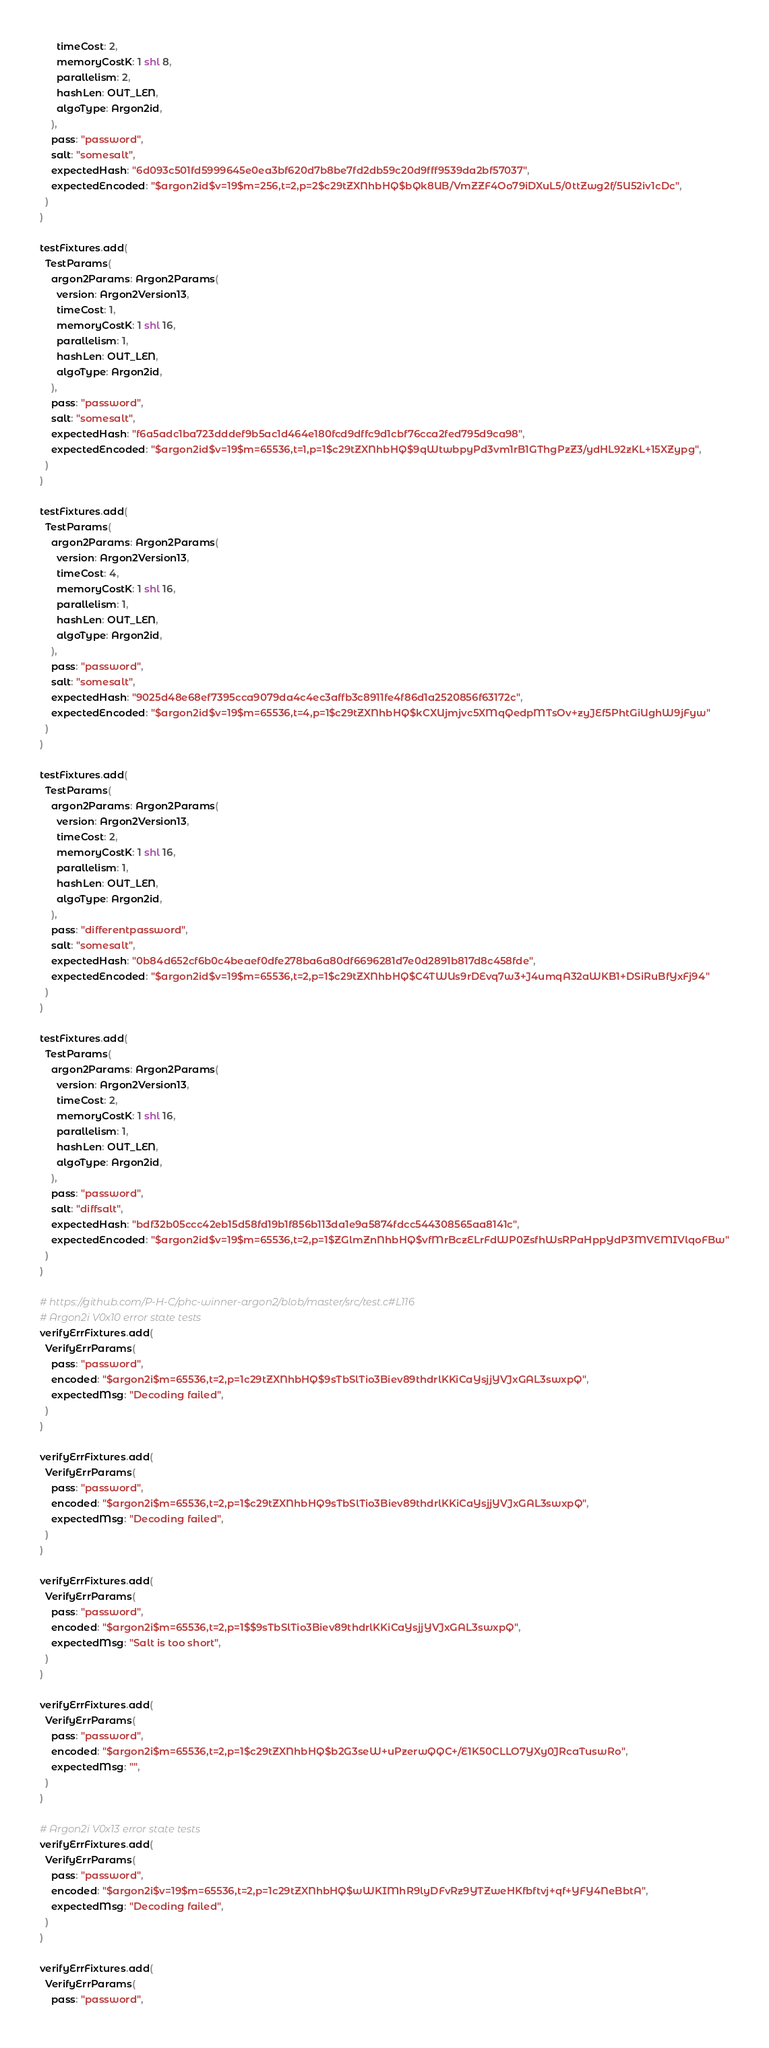<code> <loc_0><loc_0><loc_500><loc_500><_Nim_>      timeCost: 2,
      memoryCostK: 1 shl 8,
      parallelism: 2,
      hashLen: OUT_LEN,
      algoType: Argon2id,
    ),
    pass: "password",
    salt: "somesalt",
    expectedHash: "6d093c501fd5999645e0ea3bf620d7b8be7fd2db59c20d9fff9539da2bf57037",
    expectedEncoded: "$argon2id$v=19$m=256,t=2,p=2$c29tZXNhbHQ$bQk8UB/VmZZF4Oo79iDXuL5/0ttZwg2f/5U52iv1cDc",
  )
)

testFixtures.add(
  TestParams(
    argon2Params: Argon2Params(
      version: Argon2Version13,
      timeCost: 1,
      memoryCostK: 1 shl 16,
      parallelism: 1,
      hashLen: OUT_LEN,
      algoType: Argon2id,
    ),
    pass: "password",
    salt: "somesalt",
    expectedHash: "f6a5adc1ba723dddef9b5ac1d464e180fcd9dffc9d1cbf76cca2fed795d9ca98",
    expectedEncoded: "$argon2id$v=19$m=65536,t=1,p=1$c29tZXNhbHQ$9qWtwbpyPd3vm1rB1GThgPzZ3/ydHL92zKL+15XZypg",
  )
)

testFixtures.add(
  TestParams(
    argon2Params: Argon2Params(
      version: Argon2Version13,
      timeCost: 4,
      memoryCostK: 1 shl 16,
      parallelism: 1,
      hashLen: OUT_LEN,
      algoType: Argon2id,
    ),
    pass: "password",
    salt: "somesalt",
    expectedHash: "9025d48e68ef7395cca9079da4c4ec3affb3c8911fe4f86d1a2520856f63172c",
    expectedEncoded: "$argon2id$v=19$m=65536,t=4,p=1$c29tZXNhbHQ$kCXUjmjvc5XMqQedpMTsOv+zyJEf5PhtGiUghW9jFyw"
  )
)

testFixtures.add(
  TestParams(
    argon2Params: Argon2Params(
      version: Argon2Version13,
      timeCost: 2,
      memoryCostK: 1 shl 16,
      parallelism: 1,
      hashLen: OUT_LEN,
      algoType: Argon2id,
    ),
    pass: "differentpassword",
    salt: "somesalt",
    expectedHash: "0b84d652cf6b0c4beaef0dfe278ba6a80df6696281d7e0d2891b817d8c458fde",
    expectedEncoded: "$argon2id$v=19$m=65536,t=2,p=1$c29tZXNhbHQ$C4TWUs9rDEvq7w3+J4umqA32aWKB1+DSiRuBfYxFj94"
  )
)

testFixtures.add(
  TestParams(
    argon2Params: Argon2Params(
      version: Argon2Version13,
      timeCost: 2,
      memoryCostK: 1 shl 16,
      parallelism: 1,
      hashLen: OUT_LEN,
      algoType: Argon2id,
    ),
    pass: "password",
    salt: "diffsalt",
    expectedHash: "bdf32b05ccc42eb15d58fd19b1f856b113da1e9a5874fdcc544308565aa8141c",
    expectedEncoded: "$argon2id$v=19$m=65536,t=2,p=1$ZGlmZnNhbHQ$vfMrBczELrFdWP0ZsfhWsRPaHppYdP3MVEMIVlqoFBw"
  )
)

# https://github.com/P-H-C/phc-winner-argon2/blob/master/src/test.c#L116
# Argon2i V0x10 error state tests
verifyErrFixtures.add(
  VerifyErrParams(
    pass: "password",
    encoded: "$argon2i$m=65536,t=2,p=1c29tZXNhbHQ$9sTbSlTio3Biev89thdrlKKiCaYsjjYVJxGAL3swxpQ",
    expectedMsg: "Decoding failed",
  )
)

verifyErrFixtures.add(
  VerifyErrParams(
    pass: "password",
    encoded: "$argon2i$m=65536,t=2,p=1$c29tZXNhbHQ9sTbSlTio3Biev89thdrlKKiCaYsjjYVJxGAL3swxpQ",
    expectedMsg: "Decoding failed",
  )
)

verifyErrFixtures.add(
  VerifyErrParams(
    pass: "password",
    encoded: "$argon2i$m=65536,t=2,p=1$$9sTbSlTio3Biev89thdrlKKiCaYsjjYVJxGAL3swxpQ",
    expectedMsg: "Salt is too short",
  )
)

verifyErrFixtures.add(
  VerifyErrParams(
    pass: "password",
    encoded: "$argon2i$m=65536,t=2,p=1$c29tZXNhbHQ$b2G3seW+uPzerwQQC+/E1K50CLLO7YXy0JRcaTuswRo",
    expectedMsg: "",
  )
)

# Argon2i V0x13 error state tests
verifyErrFixtures.add(
  VerifyErrParams(
    pass: "password",
    encoded: "$argon2i$v=19$m=65536,t=2,p=1c29tZXNhbHQ$wWKIMhR9lyDFvRz9YTZweHKfbftvj+qf+YFY4NeBbtA",
    expectedMsg: "Decoding failed",
  )
)

verifyErrFixtures.add(
  VerifyErrParams(
    pass: "password",</code> 